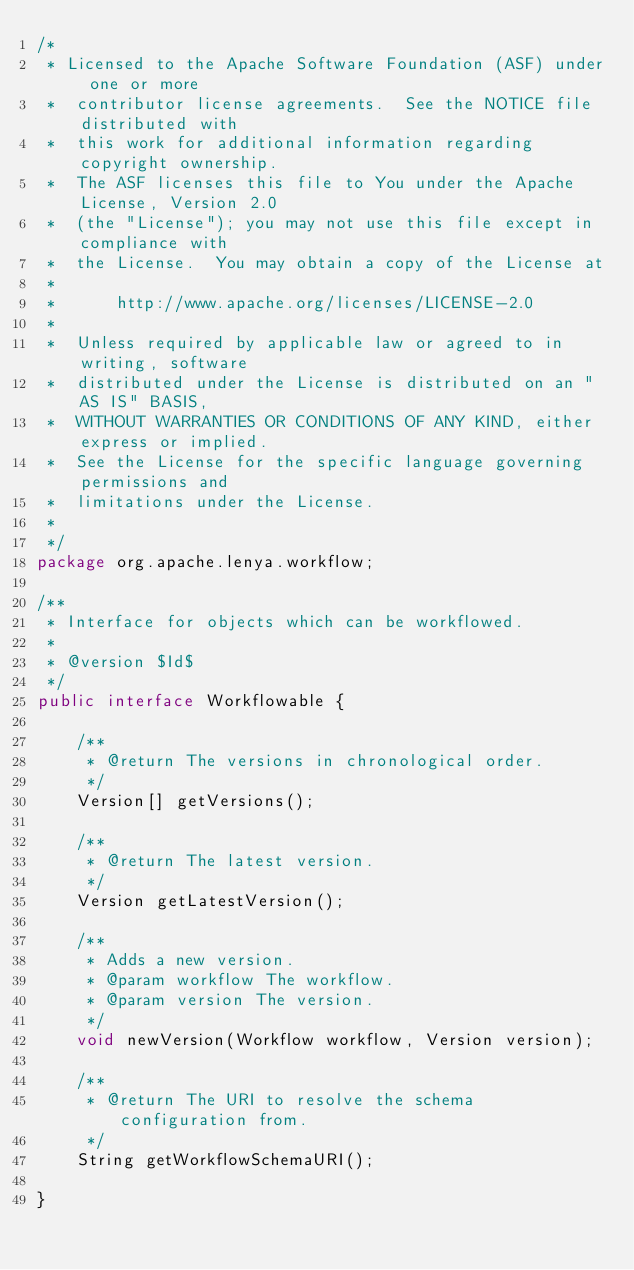<code> <loc_0><loc_0><loc_500><loc_500><_Java_>/*
 * Licensed to the Apache Software Foundation (ASF) under one or more
 *  contributor license agreements.  See the NOTICE file distributed with
 *  this work for additional information regarding copyright ownership.
 *  The ASF licenses this file to You under the Apache License, Version 2.0
 *  (the "License"); you may not use this file except in compliance with
 *  the License.  You may obtain a copy of the License at
 *
 *      http://www.apache.org/licenses/LICENSE-2.0
 *
 *  Unless required by applicable law or agreed to in writing, software
 *  distributed under the License is distributed on an "AS IS" BASIS,
 *  WITHOUT WARRANTIES OR CONDITIONS OF ANY KIND, either express or implied.
 *  See the License for the specific language governing permissions and
 *  limitations under the License.
 *
 */
package org.apache.lenya.workflow;

/**
 * Interface for objects which can be workflowed.
 *
 * @version $Id$
 */
public interface Workflowable {

    /**
     * @return The versions in chronological order.
     */
    Version[] getVersions();
    
    /**
     * @return The latest version.
     */
    Version getLatestVersion();
    
    /**
     * Adds a new version.
     * @param workflow The workflow.
     * @param version The version.
     */
    void newVersion(Workflow workflow, Version version);
    
    /**
     * @return The URI to resolve the schema configuration from.
     */
    String getWorkflowSchemaURI();
    
}
</code> 